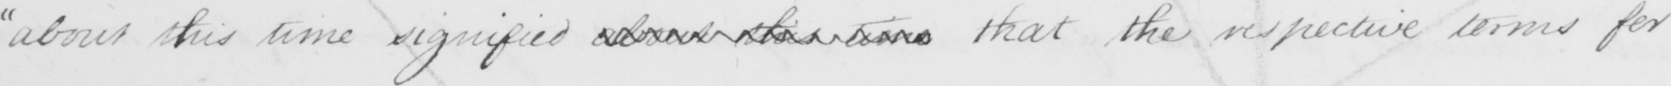What is written in this line of handwriting? " about this time signified about this time that the respective terms for 